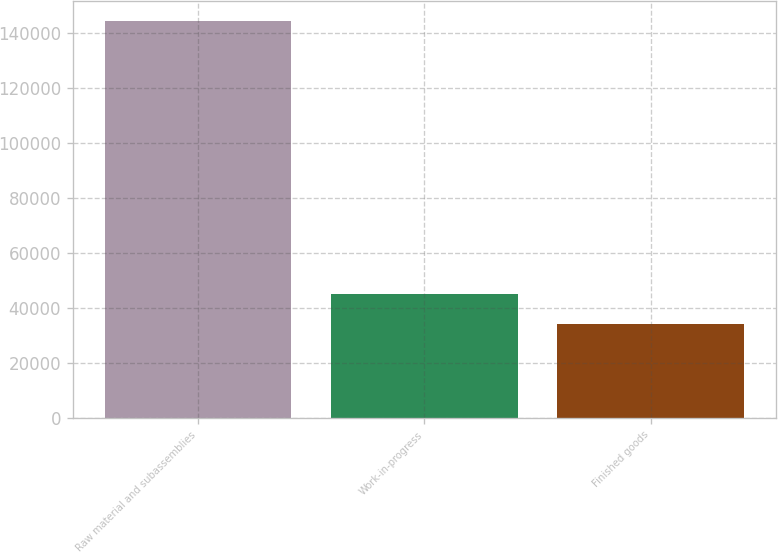Convert chart. <chart><loc_0><loc_0><loc_500><loc_500><bar_chart><fcel>Raw material and subassemblies<fcel>Work-in-progress<fcel>Finished goods<nl><fcel>144555<fcel>45247.2<fcel>34213<nl></chart> 